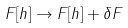Convert formula to latex. <formula><loc_0><loc_0><loc_500><loc_500>F [ h ] \rightarrow F [ h ] + \delta F</formula> 